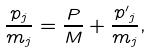Convert formula to latex. <formula><loc_0><loc_0><loc_500><loc_500>\frac { p _ { j } } { m _ { j } } = \frac { P } { M } + \frac { { p ^ { \prime } } _ { j } } { m _ { j } } ,</formula> 